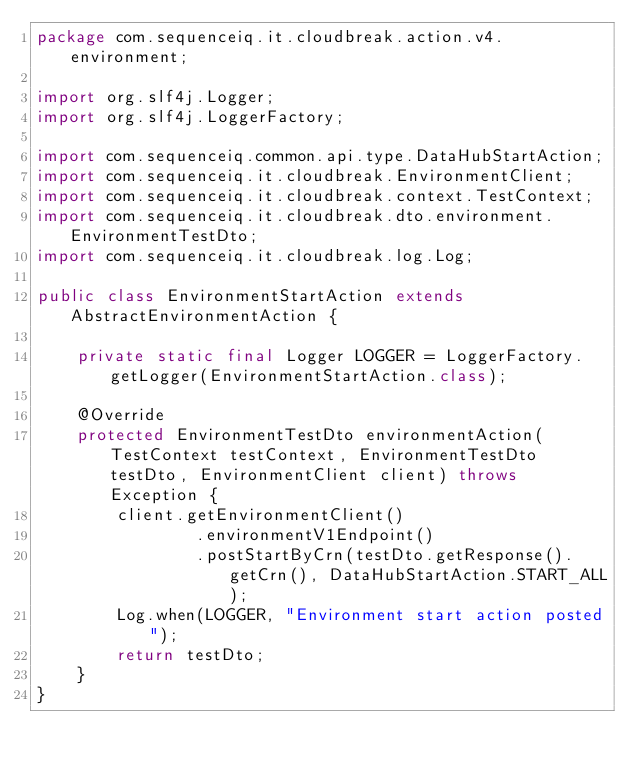Convert code to text. <code><loc_0><loc_0><loc_500><loc_500><_Java_>package com.sequenceiq.it.cloudbreak.action.v4.environment;

import org.slf4j.Logger;
import org.slf4j.LoggerFactory;

import com.sequenceiq.common.api.type.DataHubStartAction;
import com.sequenceiq.it.cloudbreak.EnvironmentClient;
import com.sequenceiq.it.cloudbreak.context.TestContext;
import com.sequenceiq.it.cloudbreak.dto.environment.EnvironmentTestDto;
import com.sequenceiq.it.cloudbreak.log.Log;

public class EnvironmentStartAction extends AbstractEnvironmentAction {

    private static final Logger LOGGER = LoggerFactory.getLogger(EnvironmentStartAction.class);

    @Override
    protected EnvironmentTestDto environmentAction(TestContext testContext, EnvironmentTestDto testDto, EnvironmentClient client) throws Exception {
        client.getEnvironmentClient()
                .environmentV1Endpoint()
                .postStartByCrn(testDto.getResponse().getCrn(), DataHubStartAction.START_ALL);
        Log.when(LOGGER, "Environment start action posted");
        return testDto;
    }
}
</code> 